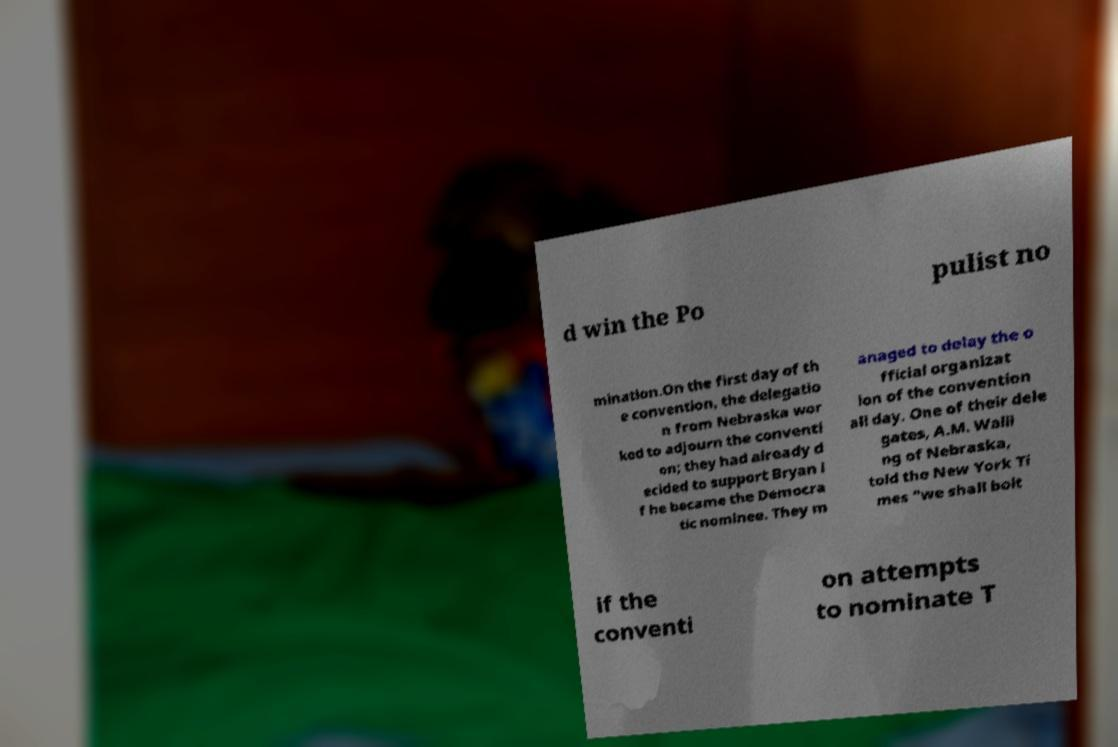For documentation purposes, I need the text within this image transcribed. Could you provide that? d win the Po pulist no mination.On the first day of th e convention, the delegatio n from Nebraska wor ked to adjourn the conventi on; they had already d ecided to support Bryan i f he became the Democra tic nominee. They m anaged to delay the o fficial organizat ion of the convention all day. One of their dele gates, A.M. Walli ng of Nebraska, told the New York Ti mes "we shall bolt if the conventi on attempts to nominate T 